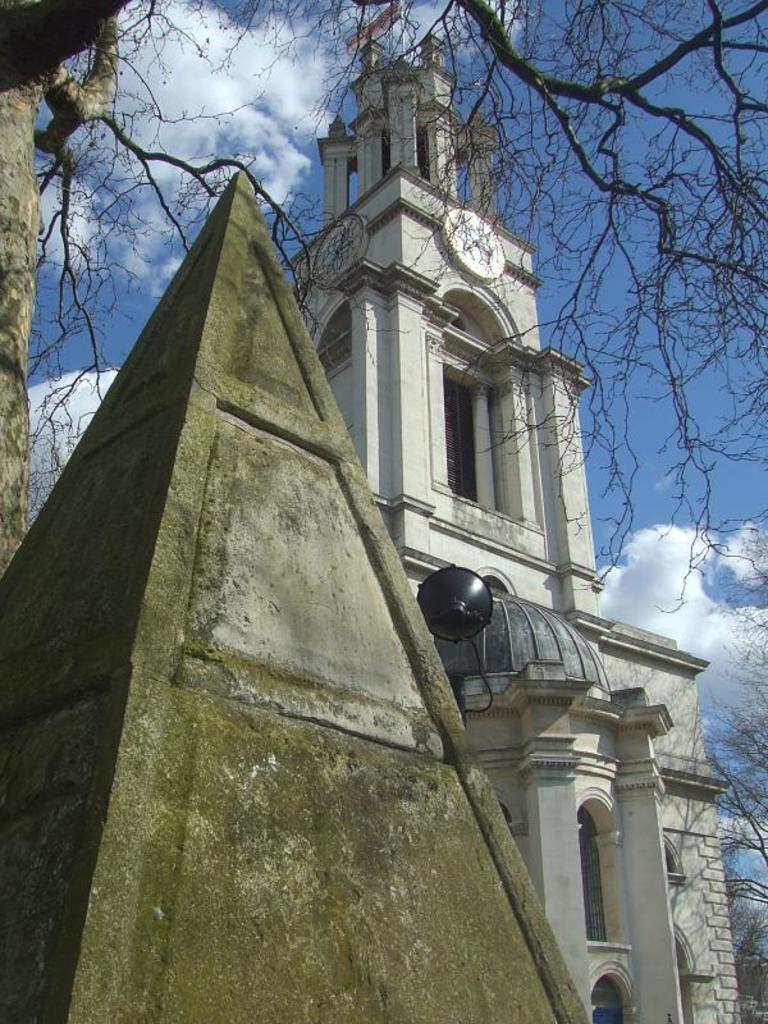In one or two sentences, can you explain what this image depicts? In this image, I can see a building and trees. On the left of the image, I can see a pyramid structure. In the background, there is the sky. 